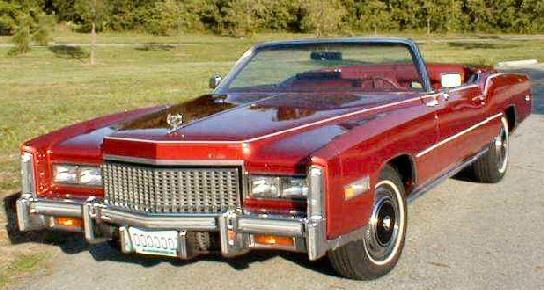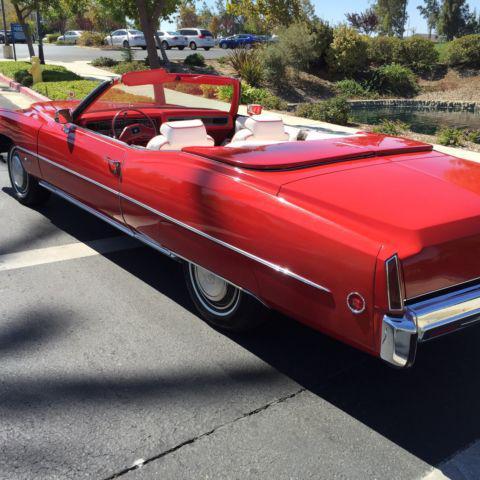The first image is the image on the left, the second image is the image on the right. For the images displayed, is the sentence "The car in the image on the left has its top up." factually correct? Answer yes or no. No. The first image is the image on the left, the second image is the image on the right. Evaluate the accuracy of this statement regarding the images: "One image shows a red soft-topped vintage car with missile-like red lights and jutting fins, and the other image shows a red topless vintage convertible.". Is it true? Answer yes or no. No. 